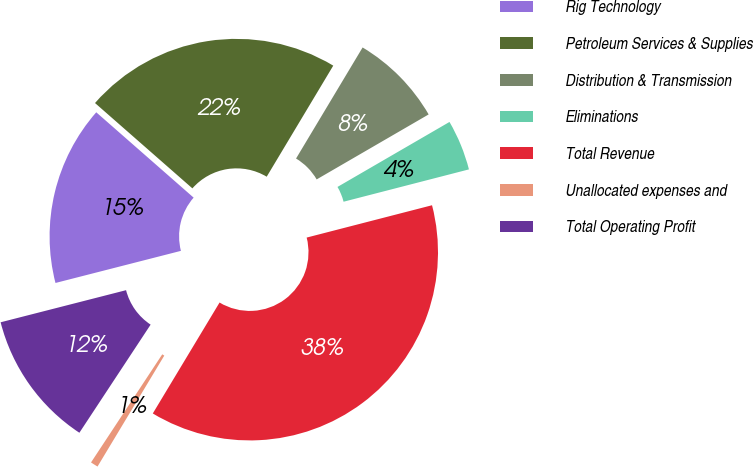<chart> <loc_0><loc_0><loc_500><loc_500><pie_chart><fcel>Rig Technology<fcel>Petroleum Services & Supplies<fcel>Distribution & Transmission<fcel>Eliminations<fcel>Total Revenue<fcel>Unallocated expenses and<fcel>Total Operating Profit<nl><fcel>15.44%<fcel>22.14%<fcel>8.04%<fcel>4.35%<fcel>37.64%<fcel>0.65%<fcel>11.74%<nl></chart> 